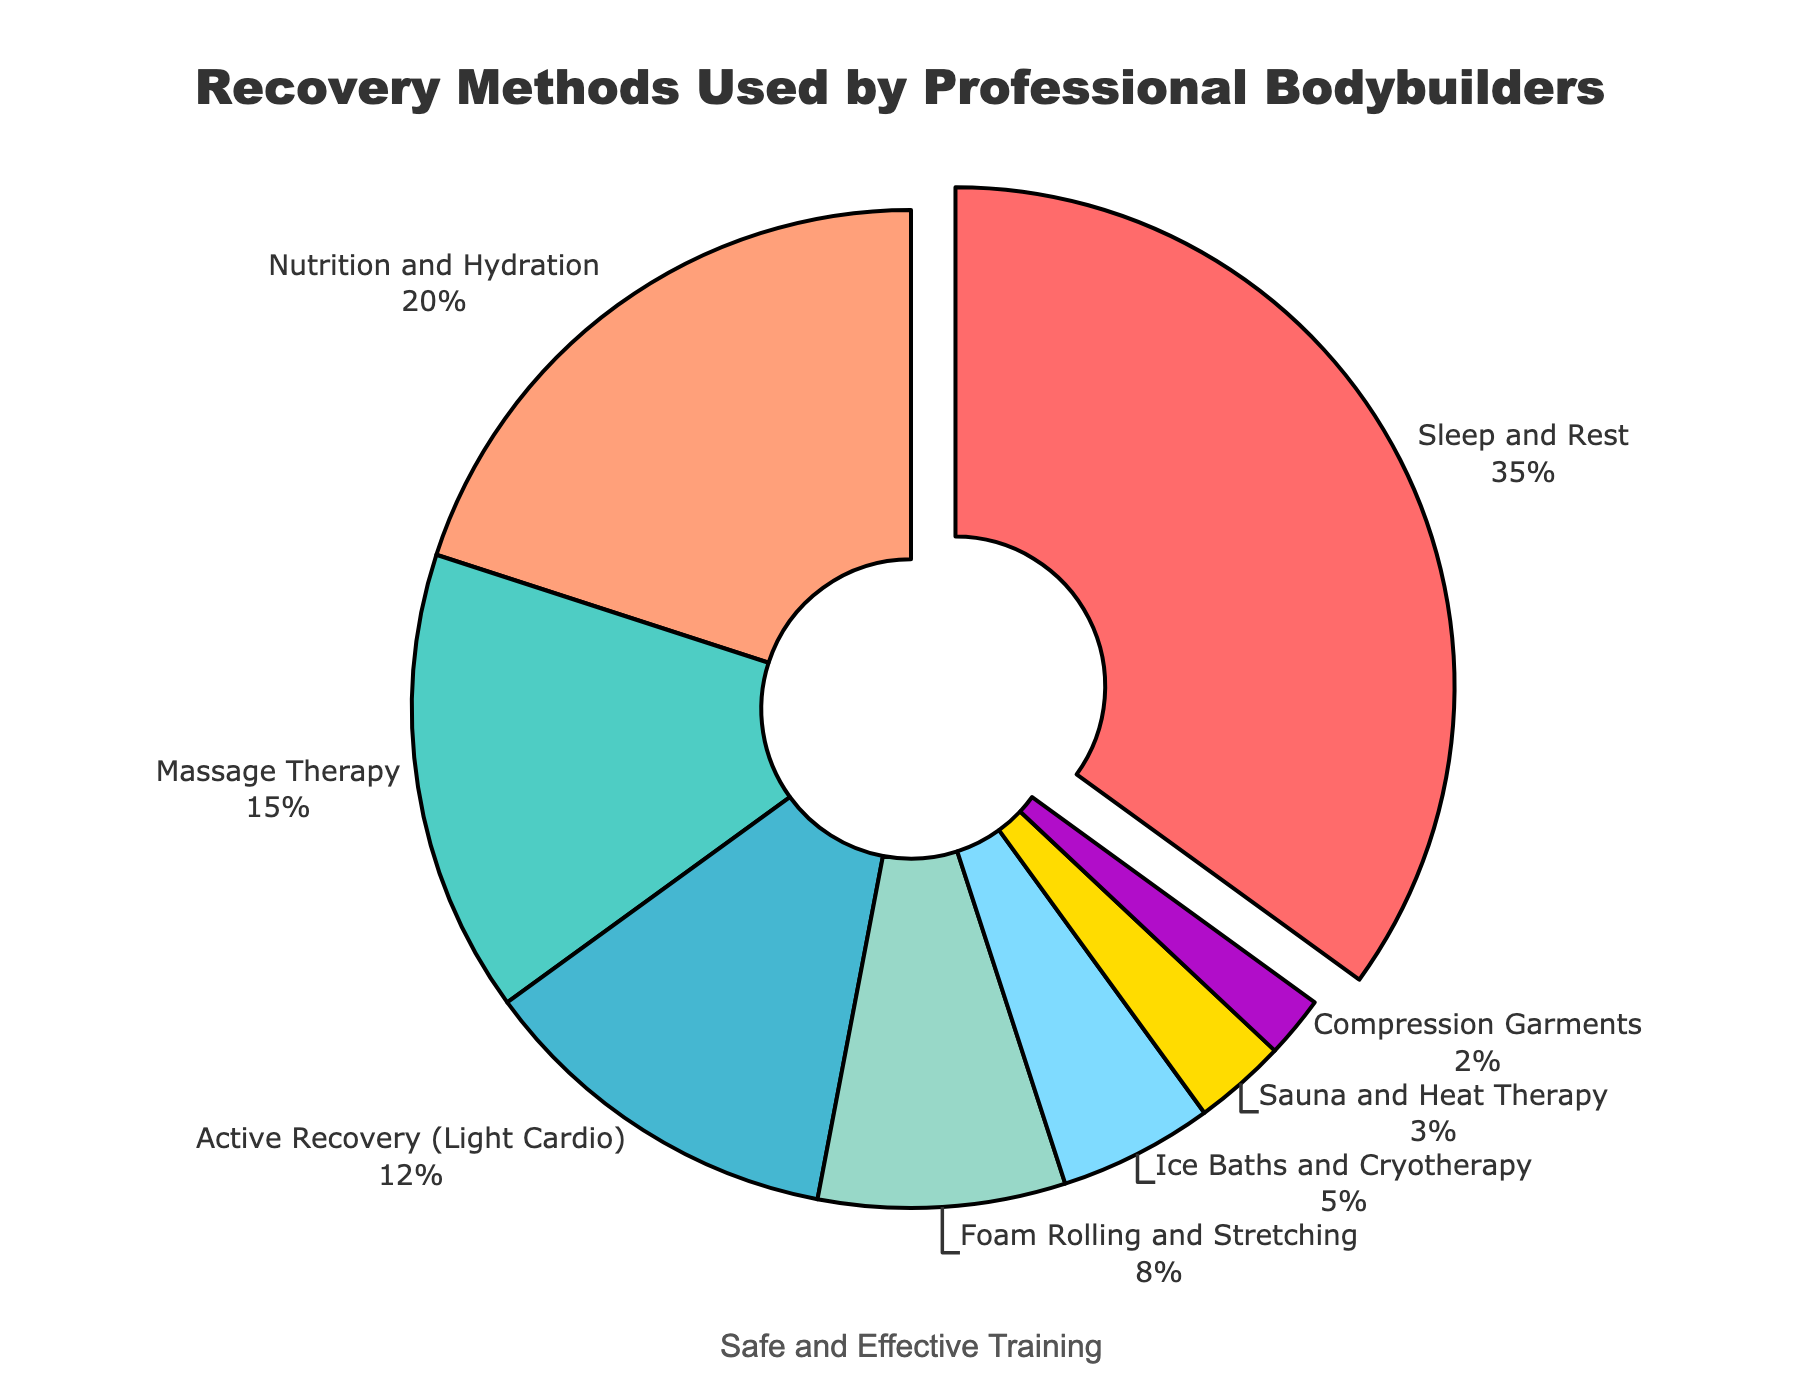What recovery method has the highest percentage? The segment with the largest area represents the recovery method with the highest percentage. "Sleep and Rest" has the largest area.
Answer: Sleep and Rest What is the combined percentage of "Massage Therapy" and "Active Recovery (Light Cardio)"? "Massage Therapy" is 15% and "Active Recovery (Light Cardio)" is 12%. Adding these together, 15 + 12 = 27%.
Answer: 27% Which recovery method has the smallest percentage allocated? The segment with the smallest area represents the recovery method with the smallest percentage. "Compression Garments" has the smallest area.
Answer: Compression Garments Is the percentage allocated to "Nutrition and Hydration" greater than to "Foam Rolling and Stretching"? "Nutrition and Hydration" is 20% while "Foam Rolling and Stretching" is 8%. Since 20% is greater than 8%, "Nutrition and Hydration" has a greater percentage.
Answer: Yes How much more percentage is allocated to "Sleep and Rest" compared to "Ice Baths and Cryotherapy"? "Sleep and Rest" is 35% while "Ice Baths and Cryotherapy" is 5%. The difference is 35 - 5 = 30%.
Answer: 30% Which recovery methods combined take up more than 40% of the total allocation? "Sleep and Rest" is 35%, "Massage Therapy" is 15%, and "Nutrition and Hydration" is 20%. Combining them: 35 + 15 = 50%, and 35 + 20 = 55%. Both sums are over 40%.
Answer: Sleep and Rest, Nutrition and Hydration What is the average percentage allocated among "Active Recovery (Light Cardio)", "Foam Rolling and Stretching", and "Sauna and Heat Therapy"? Sum the percentages: 12 + 8 + 3 = 23. Divide by 3 to find the average: 23 / 3 ≈ 7.67%.
Answer: 7.67% Are there more recovery methods below 10% or above 10%? Below 10% methods: "Foam Rolling and Stretching" (8%), "Ice Baths and Cryotherapy" (5%), "Sauna and Heat Therapy" (3%), "Compression Garments" (2%), totaling 4 methods. Above 10% methods: "Sleep and Rest" (35%), "Massage Therapy" (15%), "Active Recovery (Light Cardio)" (12%), "Nutrition and Hydration" (20%), totaling 4 methods.
Answer: Equal Which color represents "Massage Therapy"? "Massage Therapy" corresponds to the second segment after "Sleep and Rest" and is represented by the green color.
Answer: Green What is the ratio of the percentage of "Sleep and Rest" to "Active Recovery (Light Cardio)"? "Sleep and Rest" is 35% and "Active Recovery (Light Cardio)" is 12%. The ratio is 35:12 which simplifies to 35/12 ≈ 2.92:1.
Answer: 2.92:1 